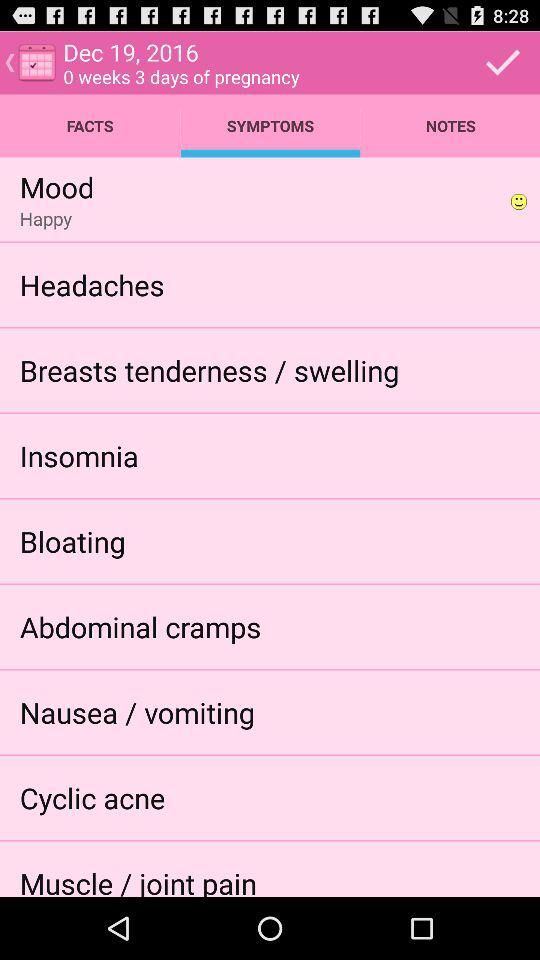How many more days of pregnancy does the user have than weeks?
Answer the question using a single word or phrase. 3 